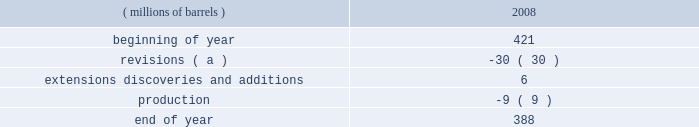Proved reserves can be added as expansions are permitted , funding is approved and certain stipulations of the joint venture agreement are satisfied .
The table sets forth changes in estimated quantities of net proved bitumen reserves for the year 2008 .
Estimated quantities of proved bitumen reserves ( millions of barrels ) 2008 .
( a ) revisions were driven primarily by price and the impact of the new royalty regime discussed below .
The above estimated quantity of net proved bitumen reserves is a forward-looking statement and is based on a number of assumptions , including ( among others ) commodity prices , volumes in-place , presently known physical data , recoverability of bitumen , industry economic conditions , levels of cash flow from operations , and other operating considerations .
To the extent these assumptions prove inaccurate , actual recoveries could be different than current estimates .
For a discussion of the proved bitumen reserves estimation process , see item 7 .
Management 2019s discussion and analysis of financial condition and results of operations 2013 critical accounting estimates 2013 estimated net recoverable reserve quantities 2013 proved bitumen reserves .
Operations at the aosp are not within the scope of statement of financial accounting standards ( 201csfas 201d ) no .
25 , 201csuspension of certain accounting requirements for oil and gas producing companies ( an amendment of financial accounting standards board ( 201cfasb 201d ) statement no .
19 ) , 201d sfas no .
69 , 201cdisclosures about oil and gas producing activities ( an amendment of fasb statements 19 , 25 , 33 and 39 ) , 201d and securities and exchange commission ( 201csec 201d ) rule 4-10 of regulation s-x ; therefore , bitumen production and reserves are not included in our supplementary information on oil and gas producing activities .
The sec has recently issued a release amending these disclosure requirements effective for annual reports on form 10-k for fiscal years ending on or after december 31 , 2009 , see item 7 .
Management 2019s discussion and analysis of financial condition and results of operations 2013 accounting standards not yet adopted for additional information .
Prior to our acquisition of western , the first fully-integrated expansion of the existing aosp facilities was approved in 2006 .
Expansion 1 , which includes construction of mining and extraction facilities at the jackpine mine , expansion of treatment facilities at the existing muskeg river mine , expansion of the scotford upgrader and development of related infrastructure , is anticipated to begin operations in late 2010 or 2011 .
When expansion 1 is complete , we will have more than 50000 bpd of net production and upgrading capacity in the canadian oil sands .
The timing and scope of future expansions and debottlenecking opportunities on existing operations remain under review .
During 2008 , the alberta government accepted the project 2019s application to have a portion of the expansion 1 capital costs form part of the muskeg river mine 2019s allowable cost recovery pool .
Due to commodity price declines in the year , royalties for 2008 were one percent of the gross mine revenue .
Commencing january 1 , 2009 , the alberta royalty regime has been amended such that royalty rates will be based on the canadian dollar ( 201ccad 201d ) equivalent monthly average west texas intermediate ( 201cwti 201d ) price .
Royalty rates will rise from a minimum of one percent to a maximum of nine percent under the gross revenue method and from a minimum of 25 percent to a maximum of 40 percent under the net revenue method .
Under both methods , the minimum royalty is based on a wti price of $ 55.00 cad per barrel and below while the maximum royalty is reached at a wti price of $ 120.00 cad per barrel and above , with a linear increase in royalty between the aforementioned prices .
The above discussion of the oil sands mining segment includes forward-looking statements concerning the anticipated completion of aosp expansion 1 .
Factors which could affect the expansion project include transportation logistics , availability of materials and labor , unforeseen hazards such as weather conditions , delays in obtaining or conditions imposed by necessary government and third-party approvals and other risks customarily associated with construction projects .
Refining , marketing and transportation refining we own and operate seven refineries in the gulf coast , midwest and upper great plains regions of the united states with an aggregate refining capacity of 1.016 million barrels per day ( 201cmmbpd 201d ) of crude oil .
During 2008 .
What percent of ending reserves were due to extensions discoveries and additions? 
Computations: (6 / 388)
Answer: 0.01546. 